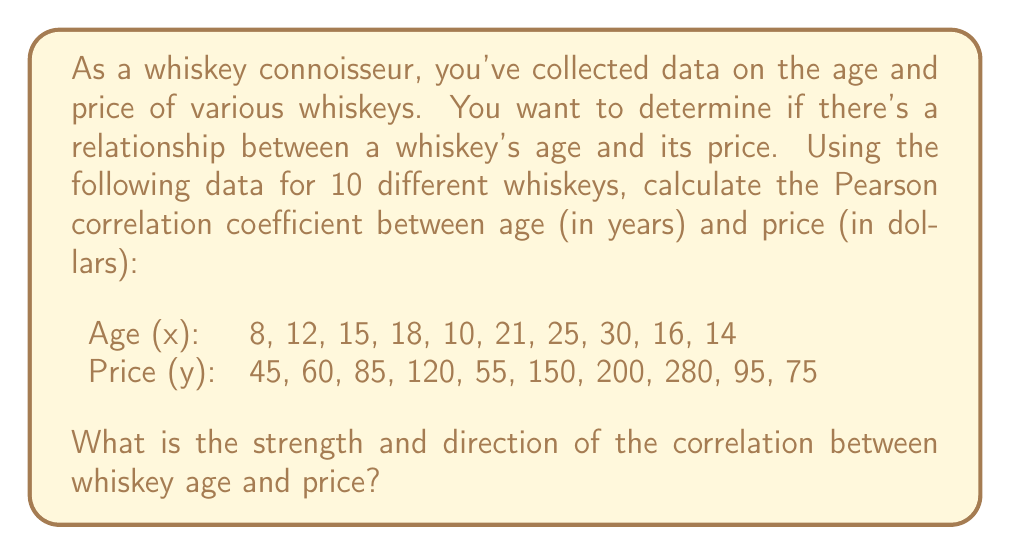Can you answer this question? To calculate the Pearson correlation coefficient (r) between whiskey age and price, we'll follow these steps:

1. Calculate the means of x (age) and y (price):
   $\bar{x} = \frac{\sum x_i}{n} = \frac{169}{10} = 16.9$
   $\bar{y} = \frac{\sum y_i}{n} = \frac{1165}{10} = 116.5$

2. Calculate the deviations from the mean for both x and y:
   $x_i - \bar{x}$ and $y_i - \bar{y}$

3. Calculate the products of these deviations:
   $(x_i - \bar{x})(y_i - \bar{y})$

4. Sum up these products:
   $\sum(x_i - \bar{x})(y_i - \bar{y}) = 5298.5$

5. Calculate the sum of squared deviations for x and y:
   $\sum(x_i - \bar{x})^2 = 478.9$
   $\sum(y_i - \bar{y})^2 = 62012.25$

6. Apply the formula for Pearson's correlation coefficient:

   $$r = \frac{\sum(x_i - \bar{x})(y_i - \bar{y})}{\sqrt{\sum(x_i - \bar{x})^2 \sum(y_i - \bar{y})^2}}$$

   $$r = \frac{5298.5}{\sqrt{478.9 \times 62012.25}} = \frac{5298.5}{5445.76} = 0.973$$

The Pearson correlation coefficient ranges from -1 to 1, where:
- 1 indicates a perfect positive correlation
- 0 indicates no correlation
- -1 indicates a perfect negative correlation

A value of 0.973 indicates a very strong positive correlation between whiskey age and price.
Answer: The Pearson correlation coefficient between whiskey age and price is 0.973, indicating a very strong positive correlation. This means that as the age of the whiskey increases, its price tends to increase as well. 